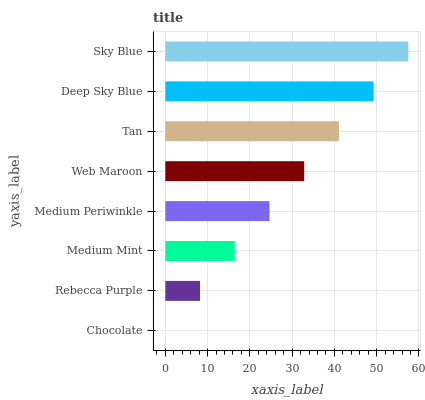Is Chocolate the minimum?
Answer yes or no. Yes. Is Sky Blue the maximum?
Answer yes or no. Yes. Is Rebecca Purple the minimum?
Answer yes or no. No. Is Rebecca Purple the maximum?
Answer yes or no. No. Is Rebecca Purple greater than Chocolate?
Answer yes or no. Yes. Is Chocolate less than Rebecca Purple?
Answer yes or no. Yes. Is Chocolate greater than Rebecca Purple?
Answer yes or no. No. Is Rebecca Purple less than Chocolate?
Answer yes or no. No. Is Web Maroon the high median?
Answer yes or no. Yes. Is Medium Periwinkle the low median?
Answer yes or no. Yes. Is Rebecca Purple the high median?
Answer yes or no. No. Is Deep Sky Blue the low median?
Answer yes or no. No. 